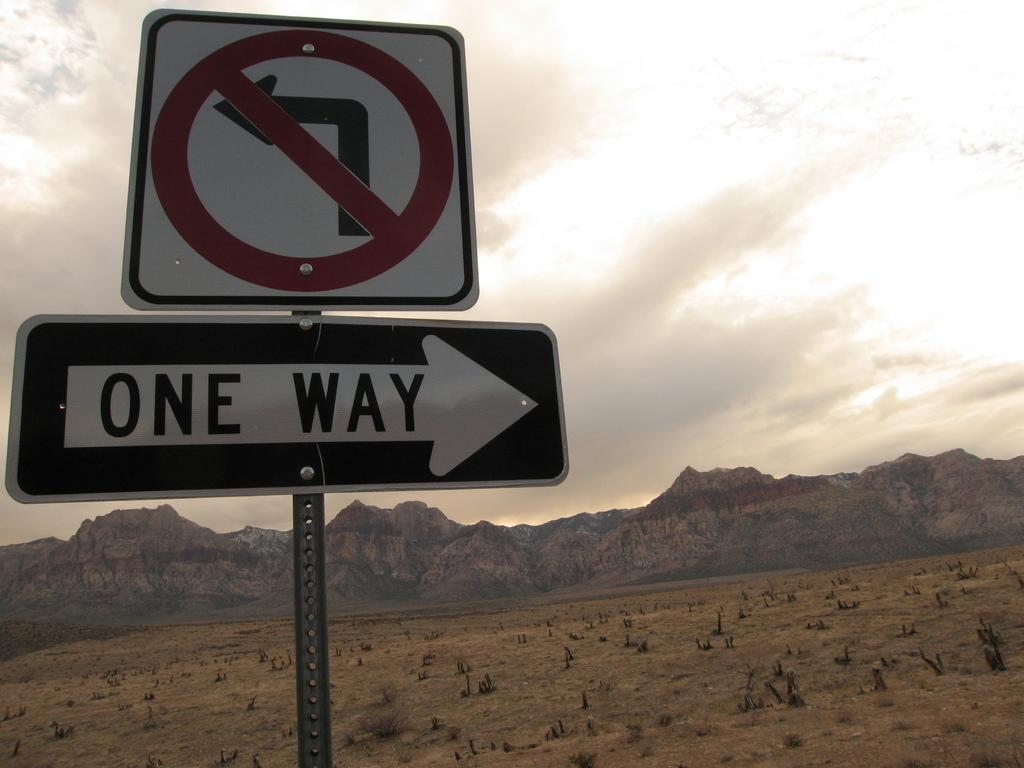<image>
Describe the image concisely. A sign in a desert environment reading 'one way.' 